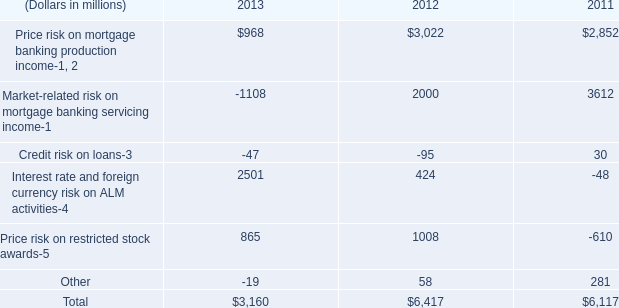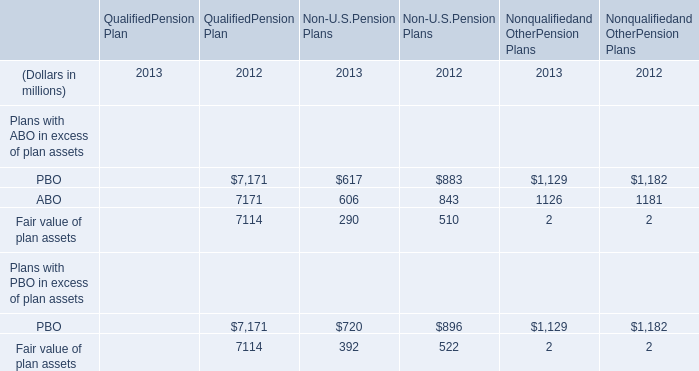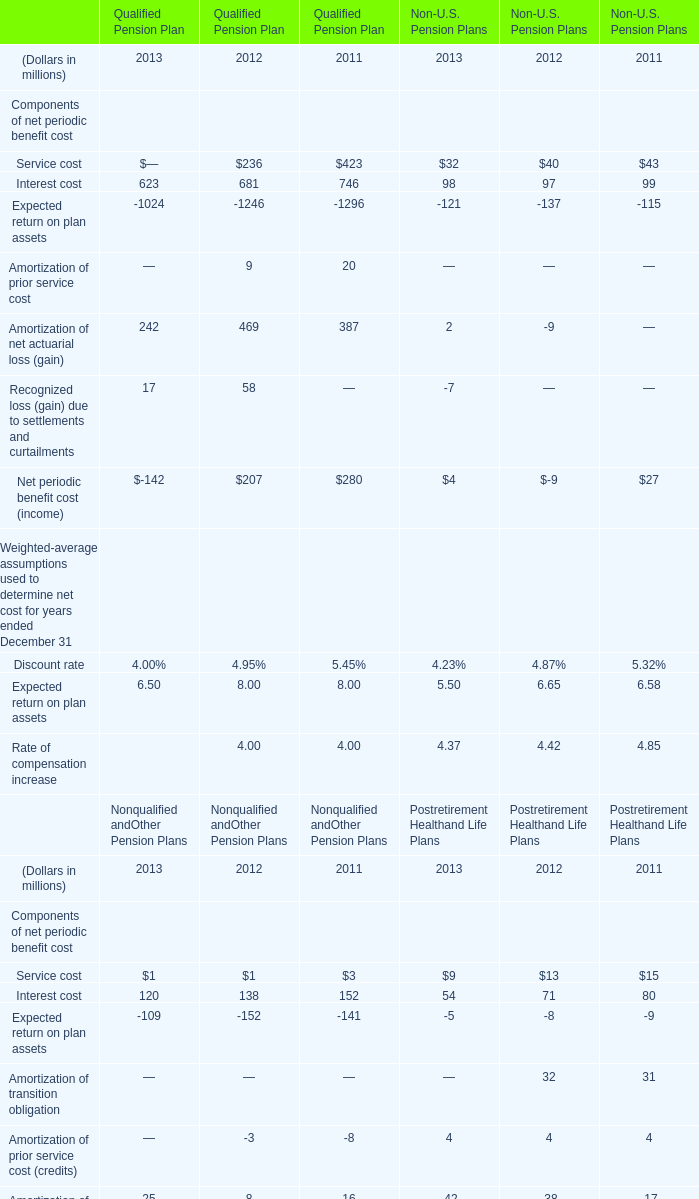Between 2012 and 2013, which year the Interest cost of Qualified Pension Plan has the fastest increasing rate? 
Answer: 2012. 